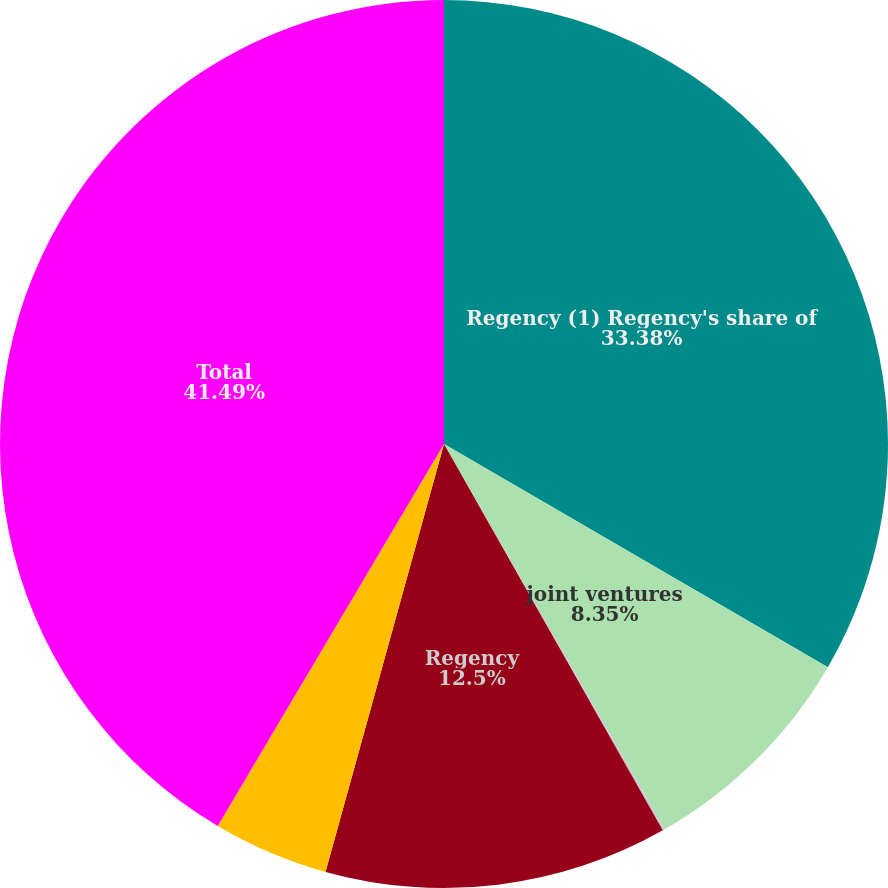Convert chart. <chart><loc_0><loc_0><loc_500><loc_500><pie_chart><fcel>Regency (1) Regency's share of<fcel>joint ventures<fcel>leases<fcel>Regency<fcel>Regency's share of joint<fcel>Total<nl><fcel>33.38%<fcel>8.35%<fcel>0.07%<fcel>12.5%<fcel>4.21%<fcel>41.49%<nl></chart> 